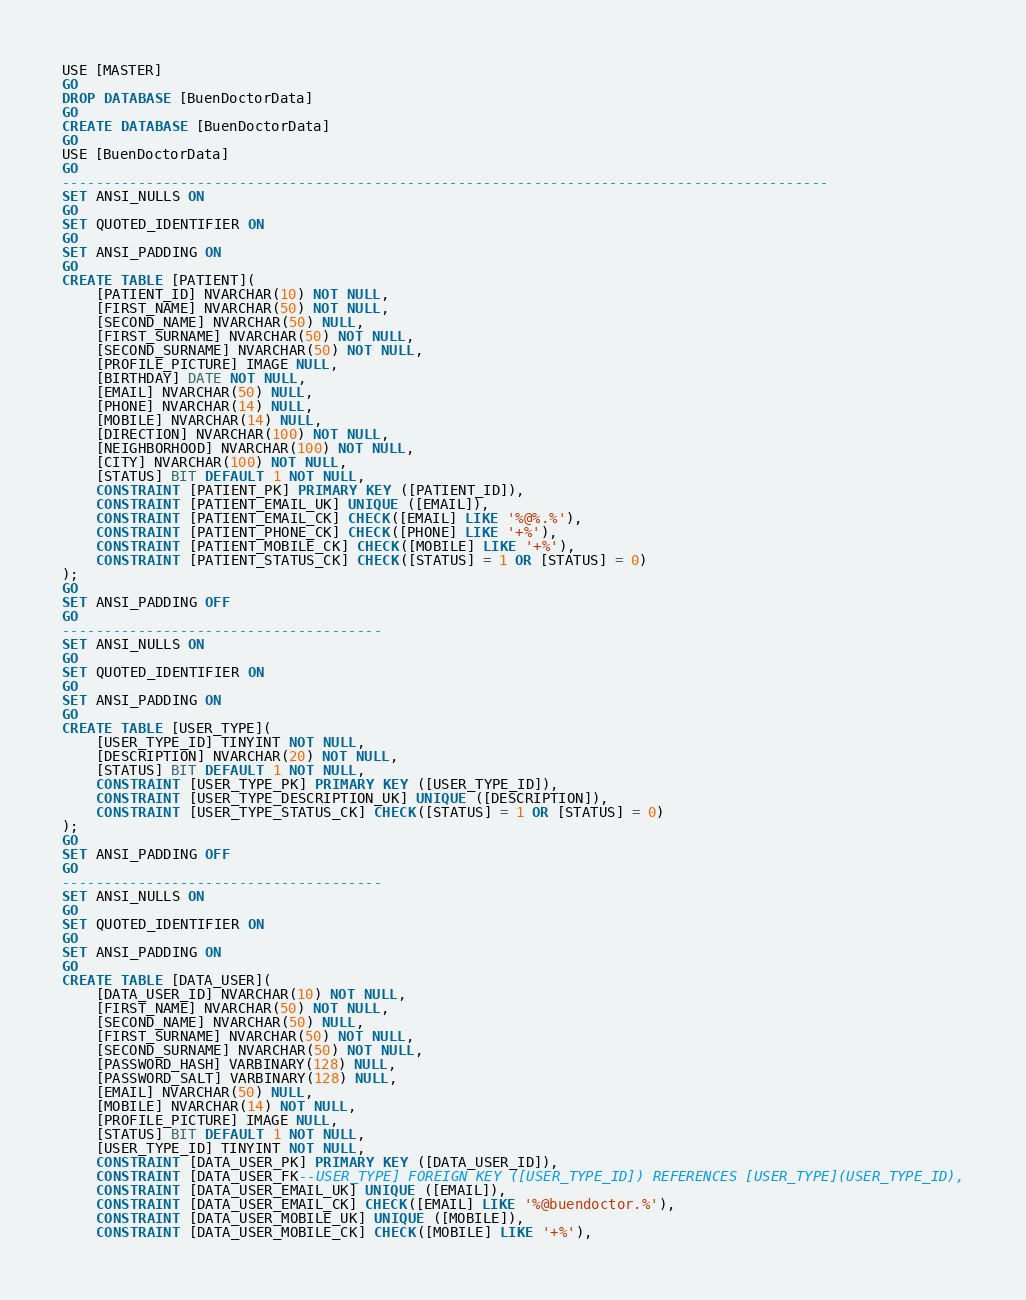<code> <loc_0><loc_0><loc_500><loc_500><_SQL_>USE [MASTER]
GO
DROP DATABASE [BuenDoctorData]
GO
CREATE DATABASE [BuenDoctorData]
GO
USE [BuenDoctorData]
GO
-------------------------------------------------------------------------------------------
SET ANSI_NULLS ON
GO
SET QUOTED_IDENTIFIER ON
GO
SET ANSI_PADDING ON
GO
CREATE TABLE [PATIENT](
    [PATIENT_ID] NVARCHAR(10) NOT NULL,
    [FIRST_NAME] NVARCHAR(50) NOT NULL,
    [SECOND_NAME] NVARCHAR(50) NULL,
	[FIRST_SURNAME] NVARCHAR(50) NOT NULL,
	[SECOND_SURNAME] NVARCHAR(50) NOT NULL,
    [PROFILE_PICTURE] IMAGE NULL,
    [BIRTHDAY] DATE NOT NULL,
	[EMAIL] NVARCHAR(50) NULL,
    [PHONE] NVARCHAR(14) NULL,
    [MOBILE] NVARCHAR(14) NULL,
    [DIRECTION] NVARCHAR(100) NOT NULL,
    [NEIGHBORHOOD] NVARCHAR(100) NOT NULL,
    [CITY] NVARCHAR(100) NOT NULL,
    [STATUS] BIT DEFAULT 1 NOT NULL,
    CONSTRAINT [PATIENT_PK] PRIMARY KEY ([PATIENT_ID]),
    CONSTRAINT [PATIENT_EMAIL_UK] UNIQUE ([EMAIL]),
    CONSTRAINT [PATIENT_EMAIL_CK] CHECK([EMAIL] LIKE '%@%.%'),
    CONSTRAINT [PATIENT_PHONE_CK] CHECK([PHONE] LIKE '+%'),
    CONSTRAINT [PATIENT_MOBILE_CK] CHECK([MOBILE] LIKE '+%'),
    CONSTRAINT [PATIENT_STATUS_CK] CHECK([STATUS] = 1 OR [STATUS] = 0) 
);
GO
SET ANSI_PADDING OFF
GO
--------------------------------------
SET ANSI_NULLS ON
GO
SET QUOTED_IDENTIFIER ON
GO
SET ANSI_PADDING ON
GO
CREATE TABLE [USER_TYPE](
	[USER_TYPE_ID] TINYINT NOT NULL,
	[DESCRIPTION] NVARCHAR(20) NOT NULL,
    [STATUS] BIT DEFAULT 1 NOT NULL,
    CONSTRAINT [USER_TYPE_PK] PRIMARY KEY ([USER_TYPE_ID]),
    CONSTRAINT [USER_TYPE_DESCRIPTION_UK] UNIQUE ([DESCRIPTION]),
    CONSTRAINT [USER_TYPE_STATUS_CK] CHECK([STATUS] = 1 OR [STATUS] = 0)
);
GO
SET ANSI_PADDING OFF
GO
--------------------------------------
SET ANSI_NULLS ON
GO
SET QUOTED_IDENTIFIER ON
GO
SET ANSI_PADDING ON
GO
CREATE TABLE [DATA_USER](
    [DATA_USER_ID] NVARCHAR(10) NOT NULL,
    [FIRST_NAME] NVARCHAR(50) NOT NULL,
    [SECOND_NAME] NVARCHAR(50) NULL,
	[FIRST_SURNAME] NVARCHAR(50) NOT NULL,
	[SECOND_SURNAME] NVARCHAR(50) NOT NULL,
	[PASSWORD_HASH] VARBINARY(128) NULL,
    [PASSWORD_SALT] VARBINARY(128) NULL,
	[EMAIL] NVARCHAR(50) NULL,
    [MOBILE] NVARCHAR(14) NOT NULL,
	[PROFILE_PICTURE] IMAGE NULL,
    [STATUS] BIT DEFAULT 1 NOT NULL,
    [USER_TYPE_ID] TINYINT NOT NULL,
    CONSTRAINT [DATA_USER_PK] PRIMARY KEY ([DATA_USER_ID]),
    CONSTRAINT [DATA_USER_FK--USER_TYPE] FOREIGN KEY ([USER_TYPE_ID]) REFERENCES [USER_TYPE](USER_TYPE_ID),
    CONSTRAINT [DATA_USER_EMAIL_UK] UNIQUE ([EMAIL]),
    CONSTRAINT [DATA_USER_EMAIL_CK] CHECK([EMAIL] LIKE '%@buendoctor.%'),
    CONSTRAINT [DATA_USER_MOBILE_UK] UNIQUE ([MOBILE]),
    CONSTRAINT [DATA_USER_MOBILE_CK] CHECK([MOBILE] LIKE '+%'),</code> 